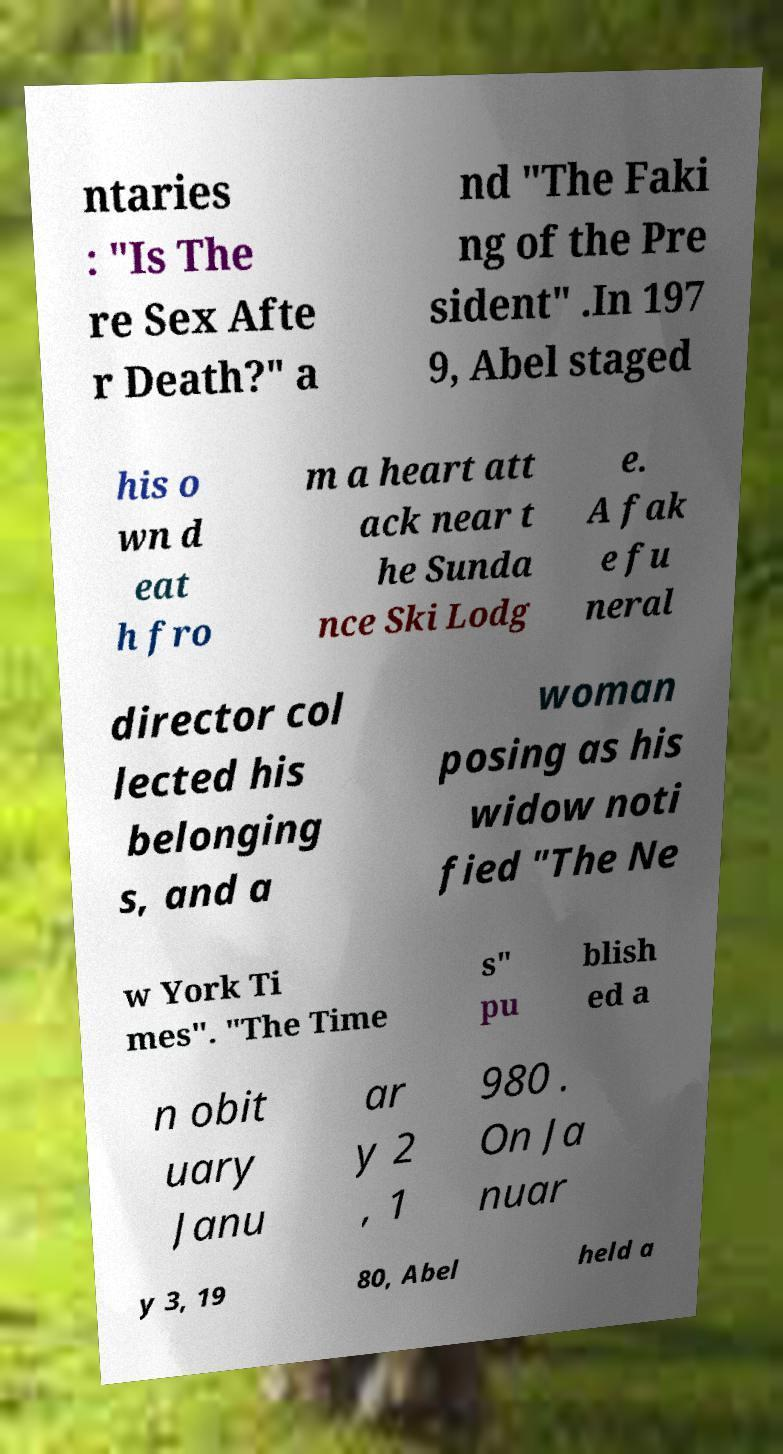For documentation purposes, I need the text within this image transcribed. Could you provide that? ntaries : "Is The re Sex Afte r Death?" a nd "The Faki ng of the Pre sident" .In 197 9, Abel staged his o wn d eat h fro m a heart att ack near t he Sunda nce Ski Lodg e. A fak e fu neral director col lected his belonging s, and a woman posing as his widow noti fied "The Ne w York Ti mes". "The Time s" pu blish ed a n obit uary Janu ar y 2 , 1 980 . On Ja nuar y 3, 19 80, Abel held a 